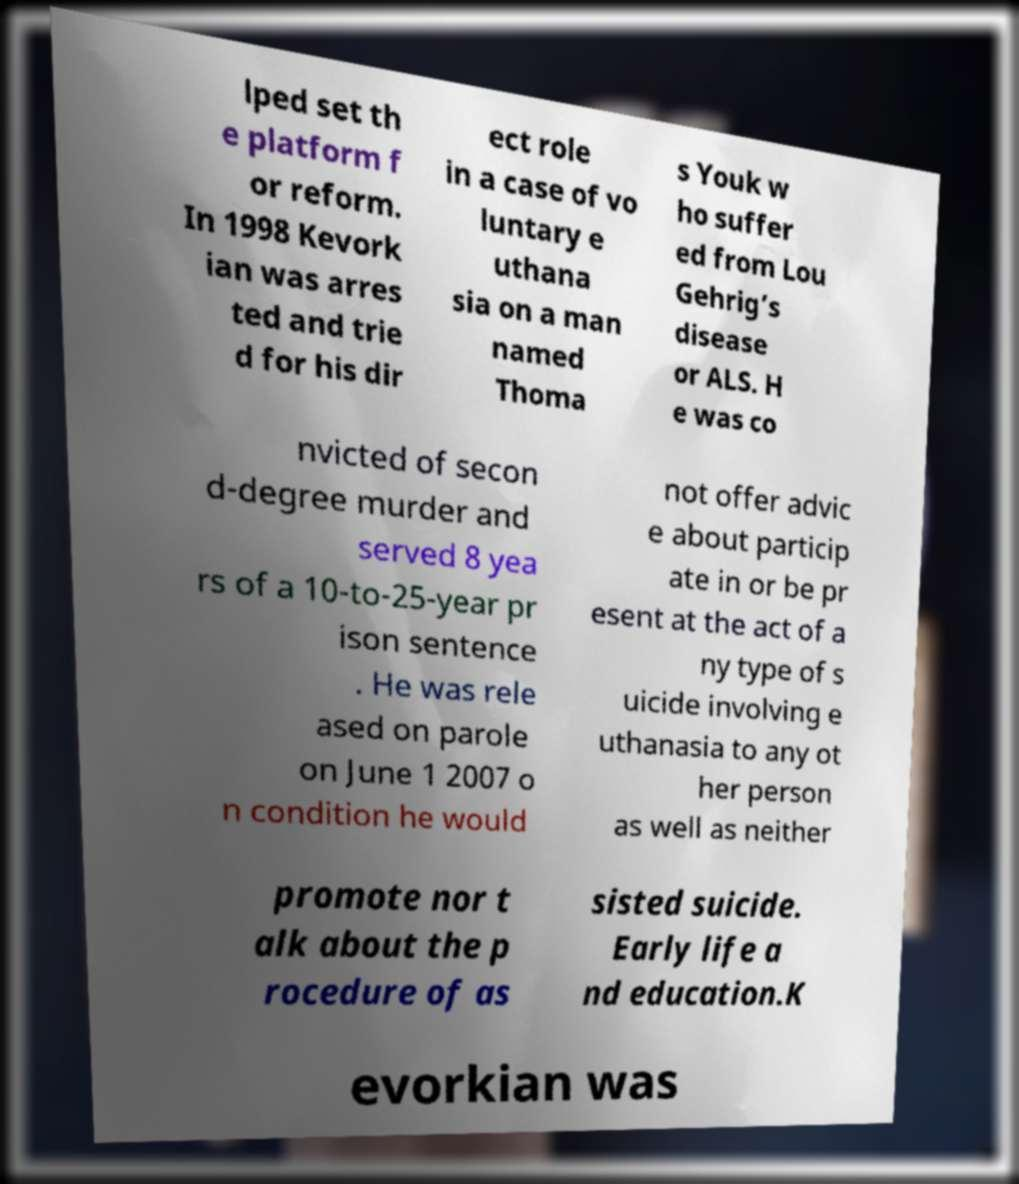Can you accurately transcribe the text from the provided image for me? lped set th e platform f or reform. In 1998 Kevork ian was arres ted and trie d for his dir ect role in a case of vo luntary e uthana sia on a man named Thoma s Youk w ho suffer ed from Lou Gehrig’s disease or ALS. H e was co nvicted of secon d-degree murder and served 8 yea rs of a 10-to-25-year pr ison sentence . He was rele ased on parole on June 1 2007 o n condition he would not offer advic e about particip ate in or be pr esent at the act of a ny type of s uicide involving e uthanasia to any ot her person as well as neither promote nor t alk about the p rocedure of as sisted suicide. Early life a nd education.K evorkian was 